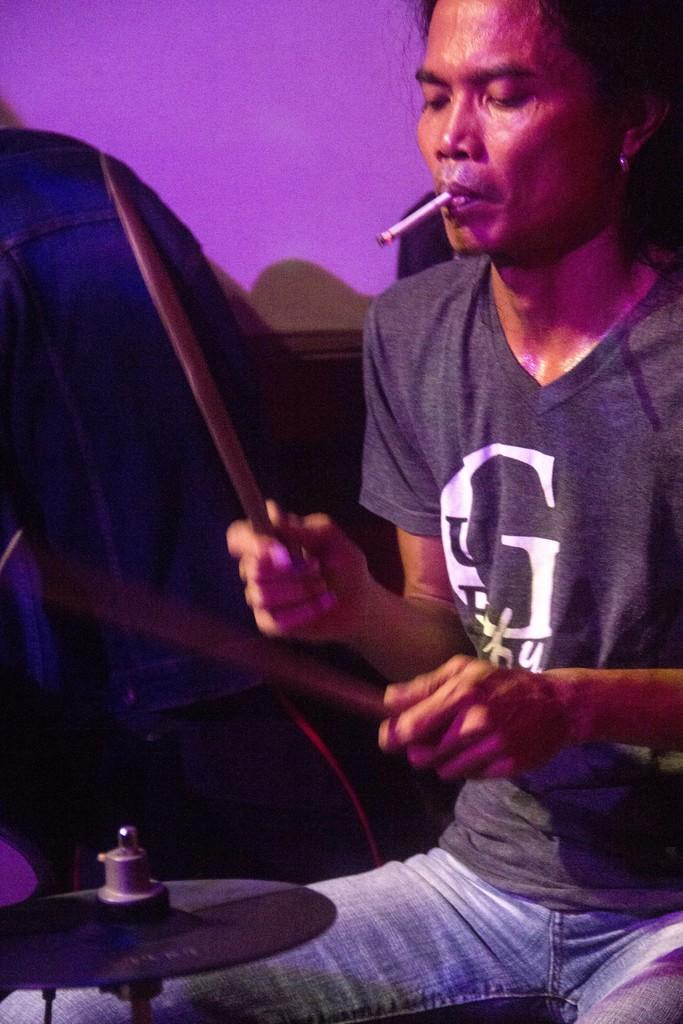<image>
Create a compact narrative representing the image presented. A man wearing a Guess shirt playing drums and smoking. 